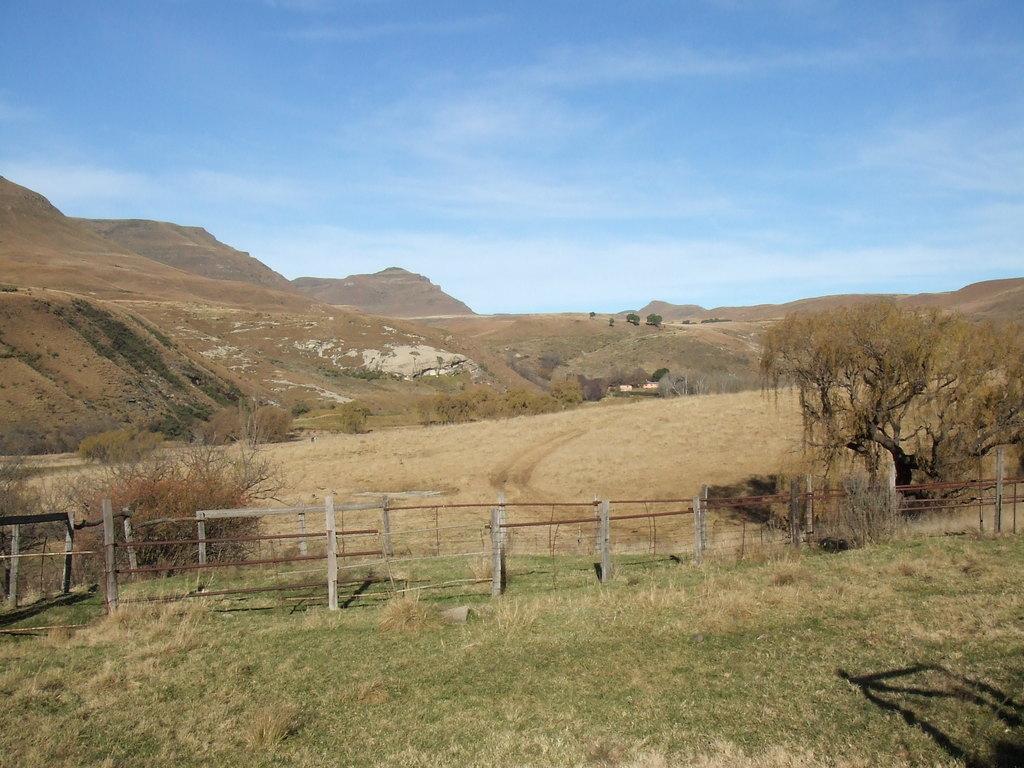Describe this image in one or two sentences. In the foreground image we can see the grass and wooden boundary. In the middle of the image we can see sand, hills and trees. On the top of the image we can see the sky. 